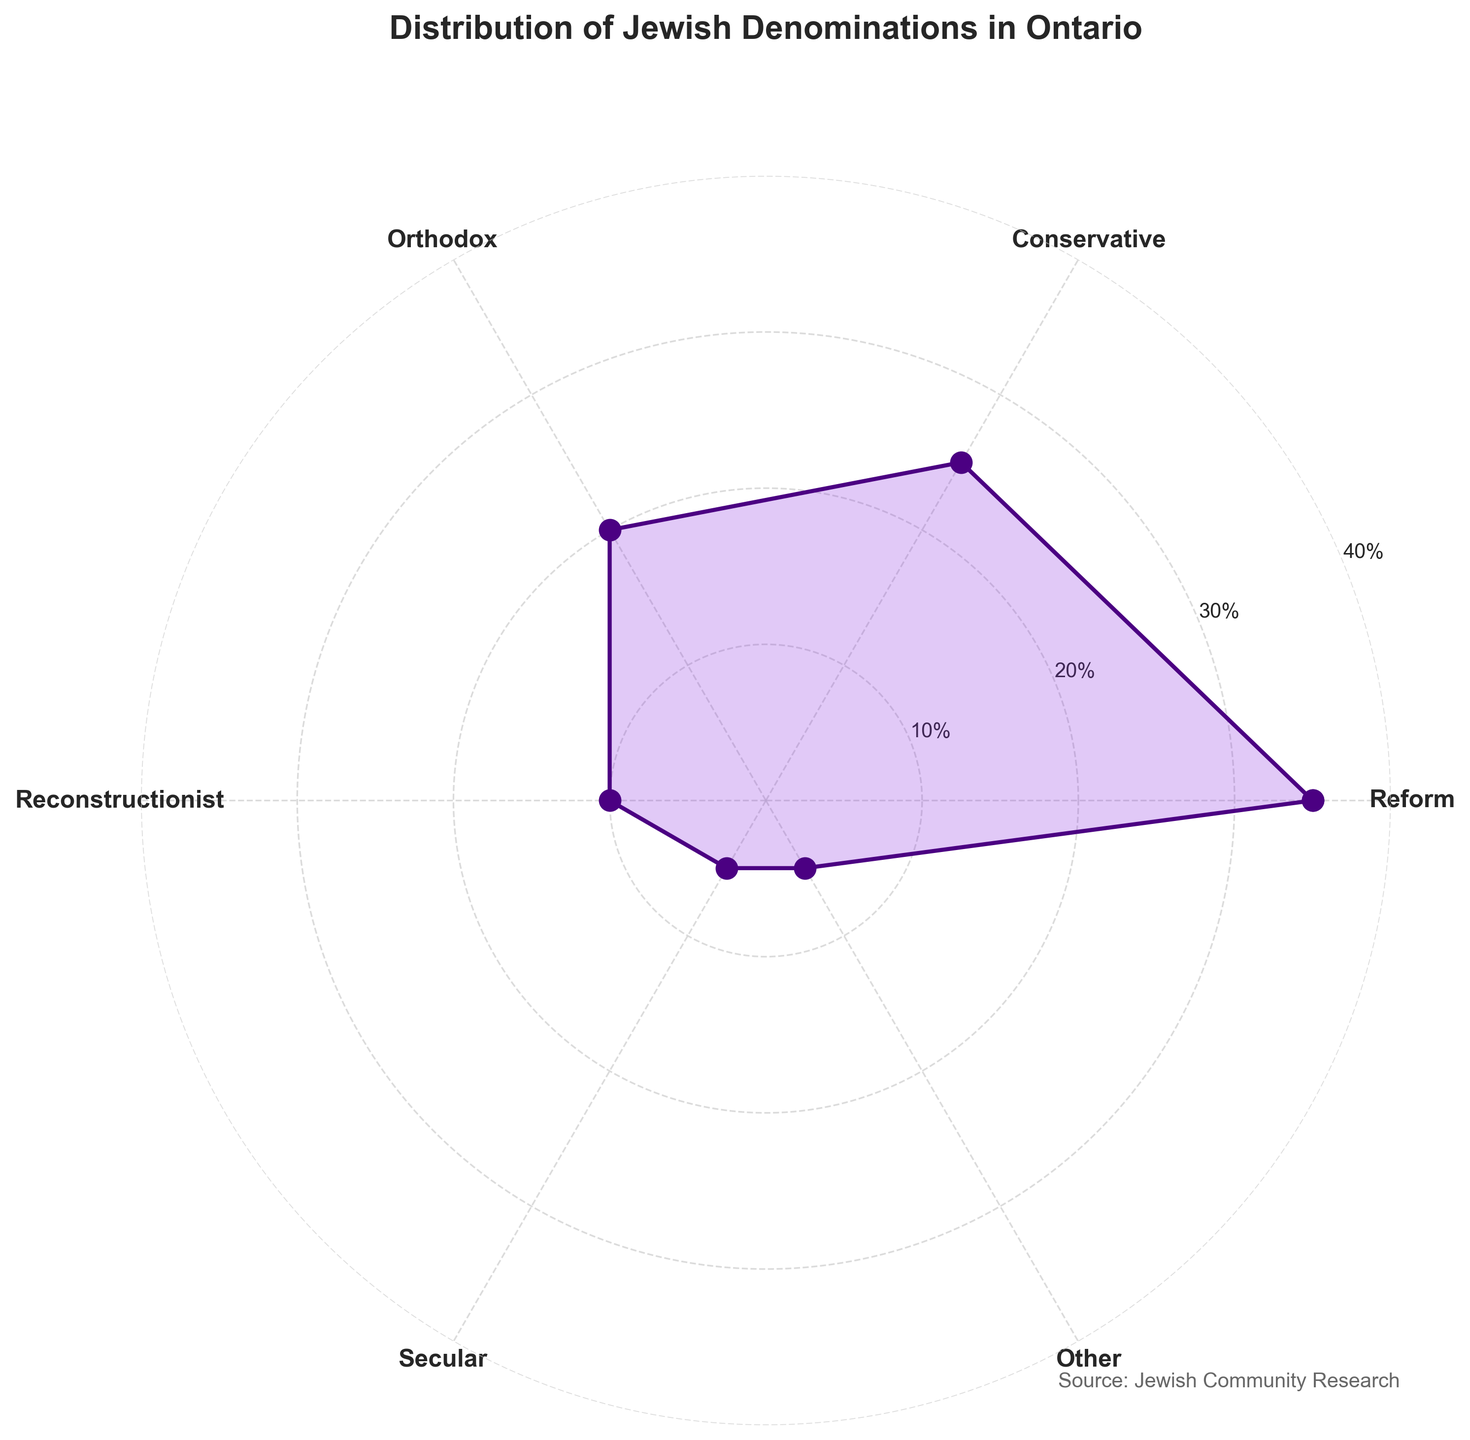What is the percentage of the Reform denomination? The percentage is directly labeled on the Reform category, which is part of the data presented in the figure.
Answer: 35% What are the second and third largest denominations in terms of percentage? Looking at the plot, we can see that the next largest sectors after Reform are Conservative and Orthodox, respectively.
Answer: Conservative and Orthodox How does the percentage of Secular compare to Reconstructionist? Secular has a smaller percentage than Reconstructionist. The plot shows 5% for Secular and 10% for Reconstructionist.
Answer: Secular is 5% and Reconstructionist is 10% Which denomination has the smallest percentage? By checking the values for each denomination, the ones with the smallest percentages are Secular and Other, both at 5%.
Answer: Secular and Other What proportion of the total population is represented by the largest and the smallest denomination combined? The largest denomination, Reform, is 35% and the smallest ones, Secular and Other, are each 5%. Summing these together: 35% + 5% + 5% = 45%.
Answer: 45% What is the difference between the percentages of the Reform and Orthodox denominations? Reform has 35%, and Orthodox has 20%. Subtracting these gives 35% - 20% = 15%.
Answer: 15% What is the mid-range value of the percentages shown on the plot? The range is the difference between the highest and lowest values, which are 35% (Reform) and 5% (Secular and Other). Mid-range is (35% + 5%) / 2 = 20%.
Answer: 20% What is the combined percentage of the Orthodox and Conservative denominations? Orthodox is 20% and Conservative is 25%; adding these together results in a total of 20% + 25% = 45%.
Answer: 45% Which denomination shows exactly half the percentage of the Orthodox denomination? Half of the percentage of Orthodox (20%) is 10%. The figure shows that Reconstructionist is exactly 10%.
Answer: Reconstructionist How many denominations are shown in the plot, including the repeated first one used to close the polygon? The figure includes six unique denominations plus the repeated Reform denomination to close the plot, making seven points in total.
Answer: 7 